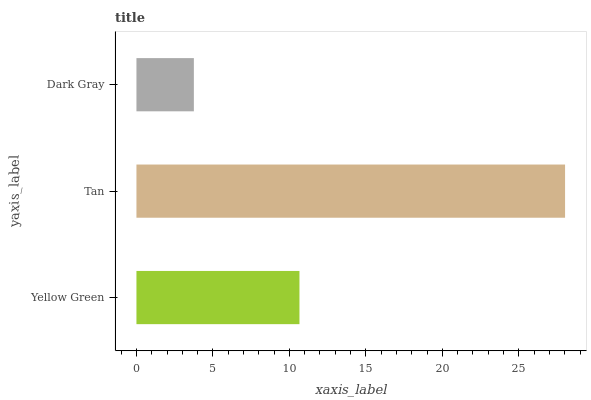Is Dark Gray the minimum?
Answer yes or no. Yes. Is Tan the maximum?
Answer yes or no. Yes. Is Tan the minimum?
Answer yes or no. No. Is Dark Gray the maximum?
Answer yes or no. No. Is Tan greater than Dark Gray?
Answer yes or no. Yes. Is Dark Gray less than Tan?
Answer yes or no. Yes. Is Dark Gray greater than Tan?
Answer yes or no. No. Is Tan less than Dark Gray?
Answer yes or no. No. Is Yellow Green the high median?
Answer yes or no. Yes. Is Yellow Green the low median?
Answer yes or no. Yes. Is Tan the high median?
Answer yes or no. No. Is Dark Gray the low median?
Answer yes or no. No. 